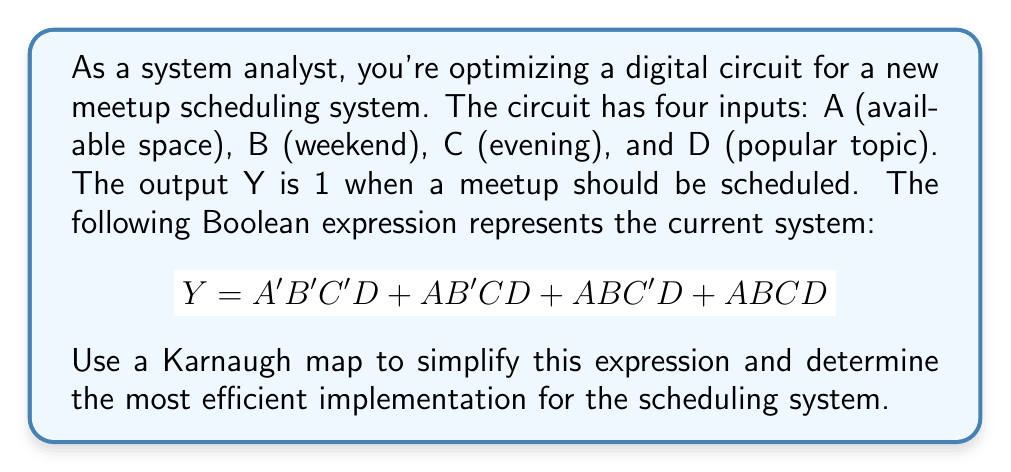Help me with this question. 1. Create a 4-variable Karnaugh map:

[asy]
unitsize(1cm);
defaultpen(fontsize(10pt));

for(int i=0; i<4; ++i) {
  for(int j=0; j<4; ++j) {
    draw((i,j)--(i+1,j)--(i+1,j+1)--(i,j+1)--cycle);
  }
}

label("00", (0.5,-0.5));
label("01", (1.5,-0.5));
label("11", (2.5,-0.5));
label("10", (3.5,-0.5));

label("00", (-0.5,0.5));
label("01", (-0.5,1.5));
label("11", (-0.5,2.5));
label("10", (-0.5,3.5));

label("AB", (-0.5,-0.5));
label("CD", (-1,-0.5));

label("0", (0.5,0.5));
label("0", (1.5,0.5));
label("0", (2.5,0.5));
label("1", (3.5,0.5));

label("0", (0.5,1.5));
label("0", (1.5,1.5));
label("1", (2.5,1.5));
label("0", (3.5,1.5));

label("0", (0.5,2.5));
label("1", (1.5,2.5));
label("1", (2.5,2.5));
label("0", (3.5,2.5));

label("0", (0.5,3.5));
label("0", (1.5,3.5));
label("1", (2.5,3.5));
label("0", (3.5,3.5));
[/asy]

2. Identify groups of 1s:
   - There's a group of two 1s in the CD=11 column (ABD term)
   - There's a single 1 in A'B'CD (can't be grouped)

3. Write the simplified expression based on the groups:
   $Y = A'B'CD + ABD$

4. Verify the simplification:
   - A'B'CD covers the original A'B'C'D term
   - ABD covers ABC'D and ABCD terms
   - The simplified expression is logically equivalent to the original

5. Interpret the result:
   The meetup should be scheduled when:
   - The space is not available (A'), it's not a weekend (B'), but it's in the evening (C) and has a popular topic (D), OR
   - There's available space (A), it's a weekend (B), and it has a popular topic (D), regardless of the time.
Answer: $Y = A'B'CD + ABD$ 